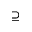<formula> <loc_0><loc_0><loc_500><loc_500>\supseteq</formula> 